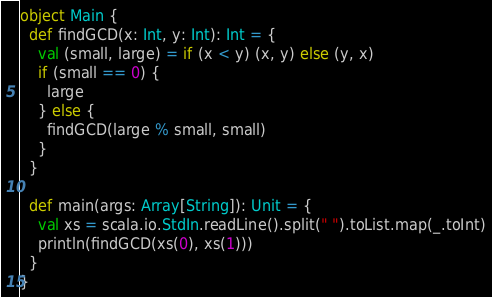Convert code to text. <code><loc_0><loc_0><loc_500><loc_500><_Scala_>object Main {
  def findGCD(x: Int, y: Int): Int = {
    val (small, large) = if (x < y) (x, y) else (y, x)
    if (small == 0) {
      large
    } else {
      findGCD(large % small, small)
    }
  }

  def main(args: Array[String]): Unit = {
    val xs = scala.io.StdIn.readLine().split(" ").toList.map(_.toInt)
    println(findGCD(xs(0), xs(1)))
  }
}</code> 